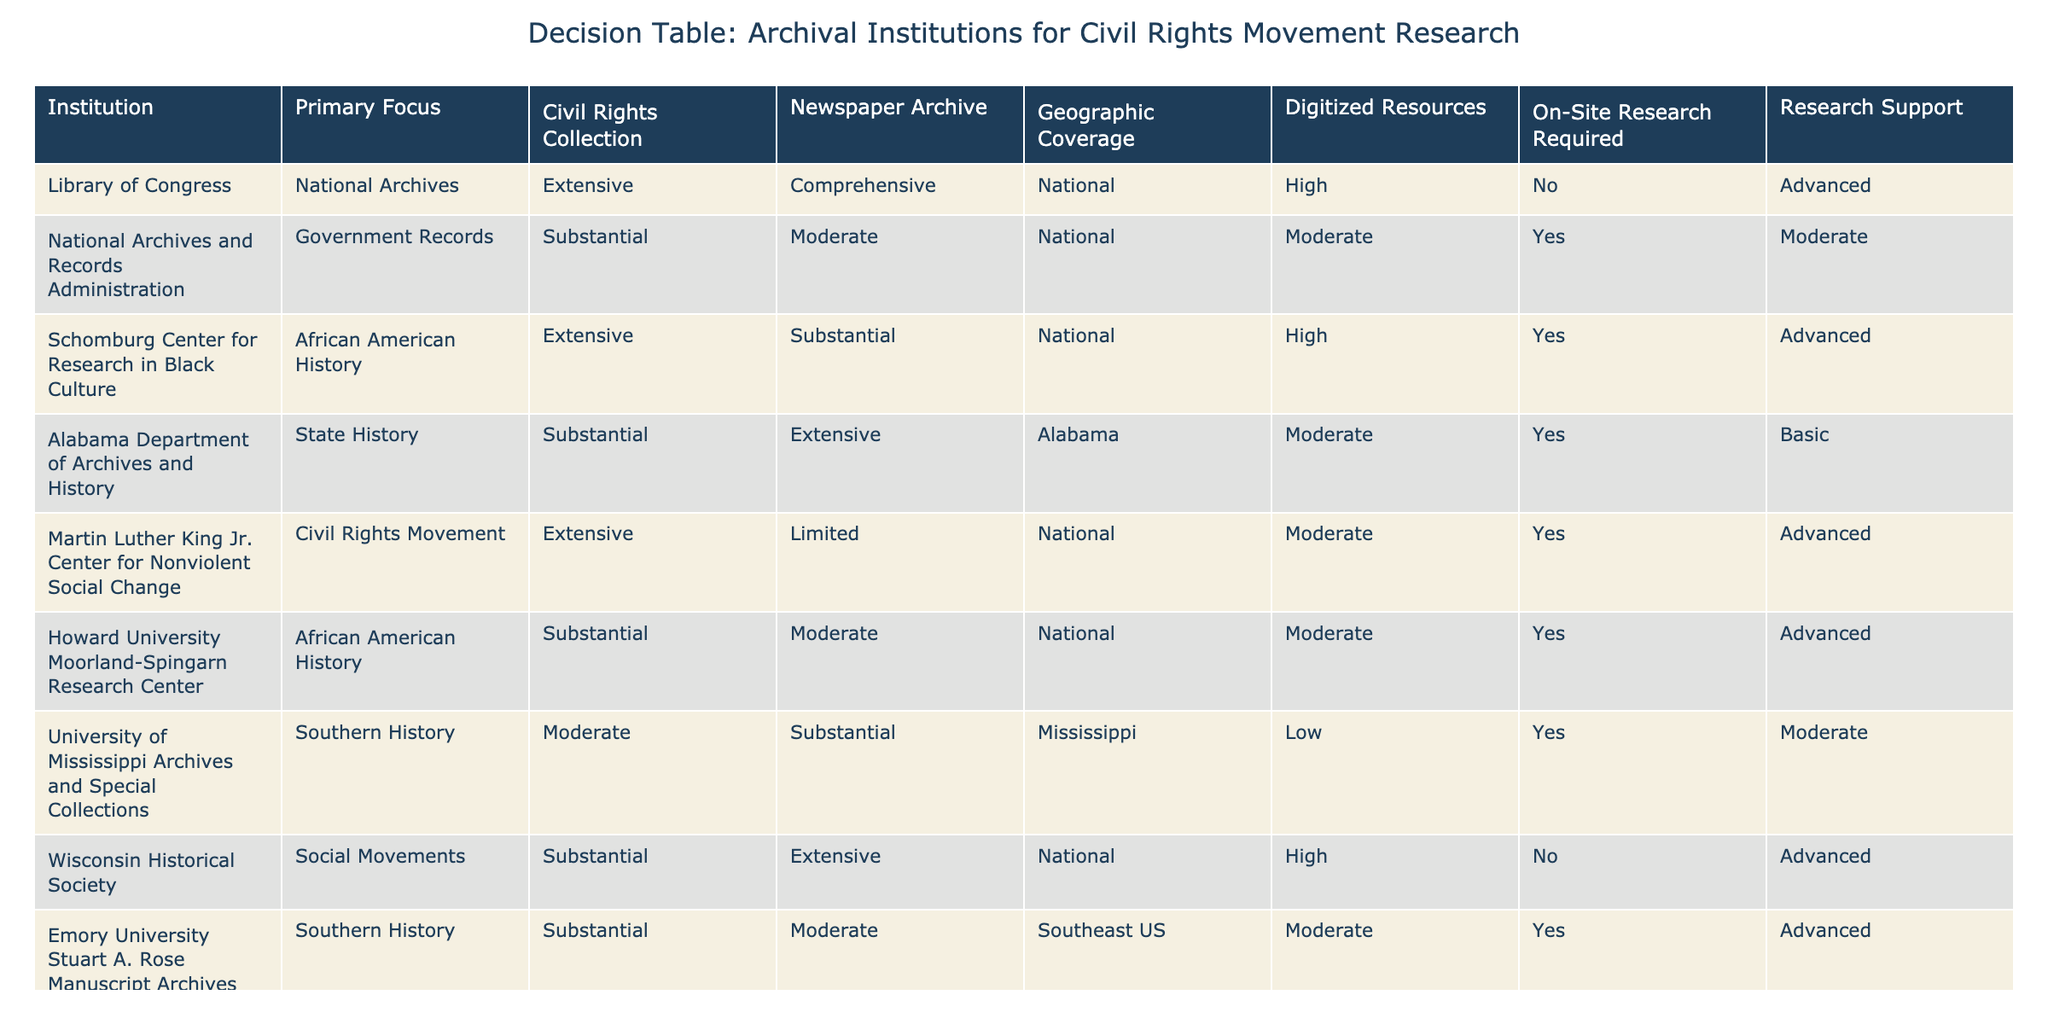What is the primary focus of the Schomburg Center for Research in Black Culture? The table shows that the primary focus of the Schomburg Center for Research in Black Culture is African American History.
Answer: African American History How many institutions offer extensive Civil Rights Collections? By reviewing the table, I see that three institutions (Library of Congress, Schomburg Center, and Martin Luther King Jr. Center) have extensive Civil Rights Collections, which can be counted directly from their rows.
Answer: 3 Does the National Archives and Records Administration have a newspaper archive? Looking at the row for the National Archives and Records Administration, it indicates a moderate newspaper archive, which confirms that they do have a newspaper archive.
Answer: Yes Which institution has limited newspaper archive resources and also focuses on the Civil Rights Movement? The table indicates that the Martin Luther King Jr. Center for Nonviolent Social Change is focused on the Civil Rights Movement and has limited newspaper archive resources.
Answer: Martin Luther King Jr. Center for Nonviolent Social Change What is the geographic coverage for Alabama Department of Archives and History? From the table, it is stated that the Alabama Department of Archives and History has a geographic coverage specific to Alabama.
Answer: Alabama How many institutions require on-site research for civil rights research? By counting the relevant rows in the "On-Site Research Required" column, I see that five institutions (National Archives, Schomburg Center, Alabama Department of Archives and History, Martin Luther King Jr. Center, Howard University) require on-site research.
Answer: 5 Which institution offers the highest level of research support and what is its primary focus? The table shows that both the Library of Congress and Wisconsin Historical Society offer advanced research support, but the Library of Congress focuses on National Archives while Wisconsin focuses on Social Movements. Both institutions provide advanced support.
Answer: Library of Congress What is the average number of civil rights collections across institutions? Summing the civil rights collection statuses (3 for extensive, 2 for substantial, 0 for moderate, and some limited as 0) gives us a total of 11 across 8 institutions. Therefore, dividing 11 by 8 institutions results in an average of 1.375.
Answer: 1.375 Which archival institution has the most digitized resources? The table shows that the Library of Congress and Wisconsin Historical Society have high digitized resources, identifying them as the institutions with the most.
Answer: Library of Congress and Wisconsin Historical Society 